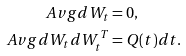<formula> <loc_0><loc_0><loc_500><loc_500>\ A v g { d W _ { t } } & = 0 , \\ \ A v g { d W _ { t } d W _ { t } ^ { T } } & = Q ( t ) d t .</formula> 